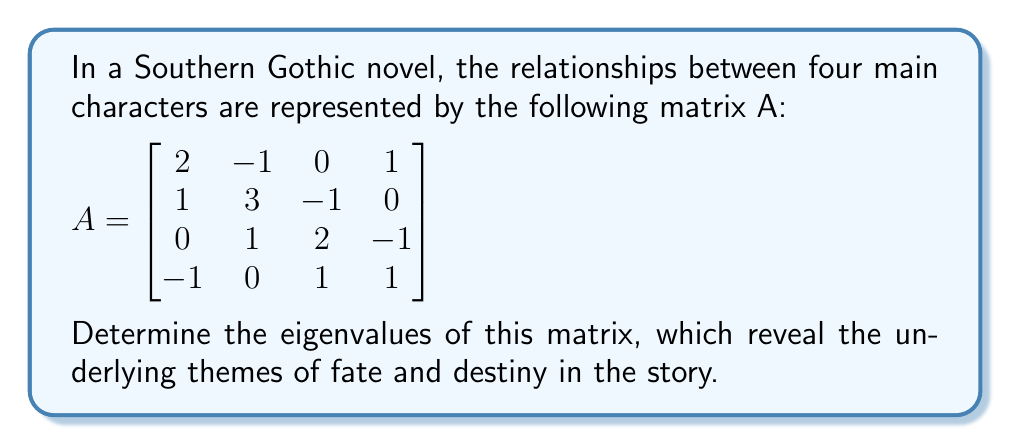Give your solution to this math problem. To find the eigenvalues, we must solve the characteristic equation:

1. Calculate $det(A - \lambda I)$, where $I$ is the 4x4 identity matrix:

$$det\begin{bmatrix}
2-\lambda & -1 & 0 & 1 \\
1 & 3-\lambda & -1 & 0 \\
0 & 1 & 2-\lambda & -1 \\
-1 & 0 & 1 & 1-\lambda
\end{bmatrix} = 0$$

2. Expand the determinant:
$$(2-\lambda)(3-\lambda)(2-\lambda)(1-\lambda) + (-1)(1)(-1)(-1) + (1)(0)(1)(-1) + (-1)(-1)(1)(1) \\ - (2-\lambda)(3-\lambda)(-1)(1) - (2-\lambda)(-1)(1)(1-\lambda) - (1)(1)(2-\lambda)(1-\lambda) = 0$$

3. Simplify:
$$(\lambda-2)(\lambda-3)(\lambda-2)(\lambda-1) - 1 - 0 + 1 \\ + (\lambda-2)(\lambda-3) - (\lambda-2)(\lambda-1) - (\lambda-2)(\lambda-1) = 0$$

4. Factor out $(\lambda-2)$:
$$(\lambda-2)[(\lambda-3)(\lambda-2)(\lambda-1) - (\lambda-3) + (\lambda-1) + (\lambda-1)] = 0$$

5. Simplify further:
$$(\lambda-2)[\lambda^3 - 6\lambda^2 + 11\lambda - 6 + 2\lambda - 3 - \lambda + 1 - \lambda + 1] = 0$$
$$(\lambda-2)(\lambda^3 - 6\lambda^2 + 11\lambda - 7) = 0$$

6. The eigenvalues are the roots of this equation:
$\lambda = 2$ (with multiplicity 1)
$\lambda^3 - 6\lambda^2 + 11\lambda - 7 = 0$ (solved using cubic formula or numerical methods)

The remaining eigenvalues are approximately:
$\lambda \approx 3.2137$
$\lambda \approx 1.5794$
$\lambda \approx 1.2069$
Answer: $\lambda_1 = 2$, $\lambda_2 \approx 3.2137$, $\lambda_3 \approx 1.5794$, $\lambda_4 \approx 1.2069$ 